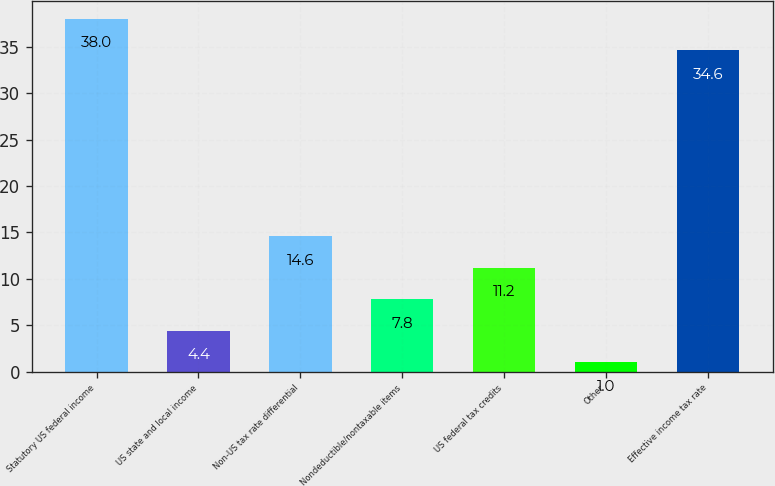Convert chart to OTSL. <chart><loc_0><loc_0><loc_500><loc_500><bar_chart><fcel>Statutory US federal income<fcel>US state and local income<fcel>Non-US tax rate differential<fcel>Nondeductible/nontaxable items<fcel>US federal tax credits<fcel>Other<fcel>Effective income tax rate<nl><fcel>38<fcel>4.4<fcel>14.6<fcel>7.8<fcel>11.2<fcel>1<fcel>34.6<nl></chart> 